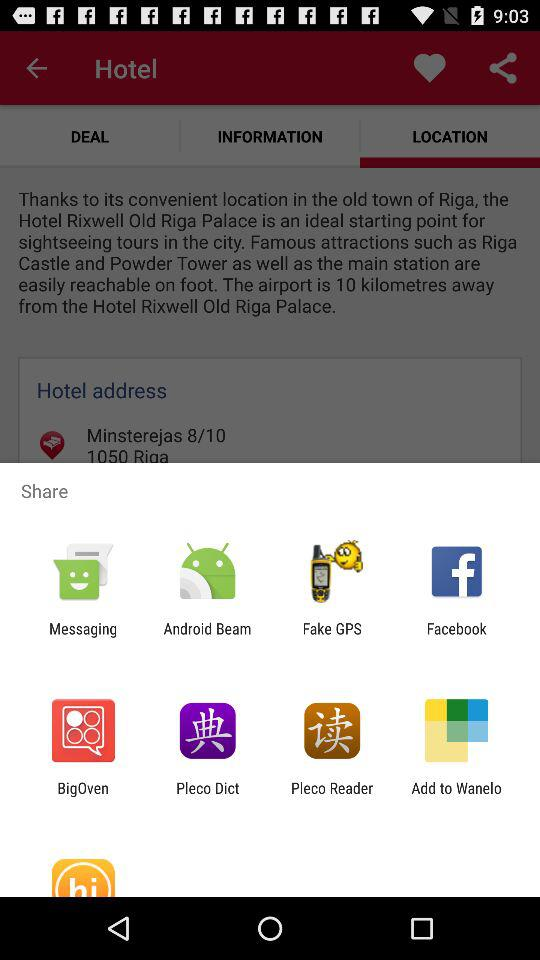What is the deal on the hotel?
When the provided information is insufficient, respond with <no answer>. <no answer> 